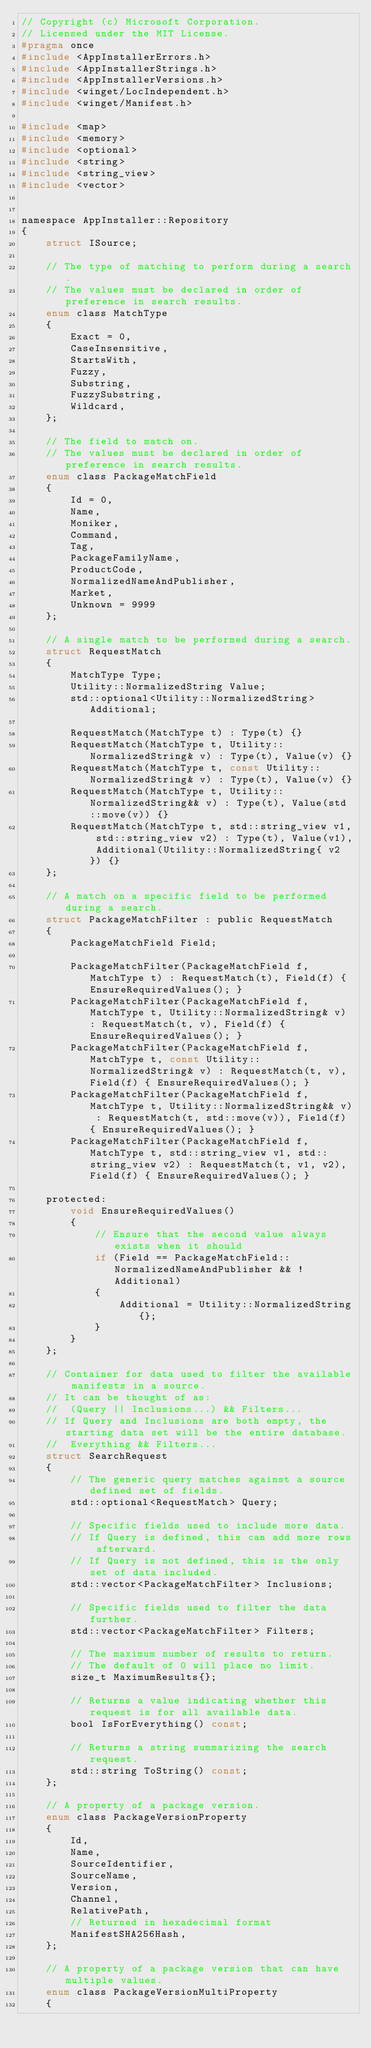<code> <loc_0><loc_0><loc_500><loc_500><_C_>// Copyright (c) Microsoft Corporation.
// Licensed under the MIT License.
#pragma once
#include <AppInstallerErrors.h>
#include <AppInstallerStrings.h>
#include <AppInstallerVersions.h>
#include <winget/LocIndependent.h>
#include <winget/Manifest.h>

#include <map>
#include <memory>
#include <optional>
#include <string>
#include <string_view>
#include <vector>


namespace AppInstaller::Repository
{
    struct ISource;

    // The type of matching to perform during a search.
    // The values must be declared in order of preference in search results.
    enum class MatchType
    {
        Exact = 0,
        CaseInsensitive,
        StartsWith,
        Fuzzy,
        Substring,
        FuzzySubstring,
        Wildcard,
    };

    // The field to match on.
    // The values must be declared in order of preference in search results.
    enum class PackageMatchField
    {
        Id = 0,
        Name,
        Moniker,
        Command,
        Tag,
        PackageFamilyName,
        ProductCode,
        NormalizedNameAndPublisher,
        Market,
        Unknown = 9999
    };

    // A single match to be performed during a search.
    struct RequestMatch
    {
        MatchType Type;
        Utility::NormalizedString Value;
        std::optional<Utility::NormalizedString> Additional;

        RequestMatch(MatchType t) : Type(t) {}
        RequestMatch(MatchType t, Utility::NormalizedString& v) : Type(t), Value(v) {}
        RequestMatch(MatchType t, const Utility::NormalizedString& v) : Type(t), Value(v) {}
        RequestMatch(MatchType t, Utility::NormalizedString&& v) : Type(t), Value(std::move(v)) {}
        RequestMatch(MatchType t, std::string_view v1, std::string_view v2) : Type(t), Value(v1), Additional(Utility::NormalizedString{ v2 }) {}
    };

    // A match on a specific field to be performed during a search.
    struct PackageMatchFilter : public RequestMatch
    {
        PackageMatchField Field;

        PackageMatchFilter(PackageMatchField f, MatchType t) : RequestMatch(t), Field(f) { EnsureRequiredValues(); }
        PackageMatchFilter(PackageMatchField f, MatchType t, Utility::NormalizedString& v) : RequestMatch(t, v), Field(f) { EnsureRequiredValues(); }
        PackageMatchFilter(PackageMatchField f, MatchType t, const Utility::NormalizedString& v) : RequestMatch(t, v), Field(f) { EnsureRequiredValues(); }
        PackageMatchFilter(PackageMatchField f, MatchType t, Utility::NormalizedString&& v) : RequestMatch(t, std::move(v)), Field(f) { EnsureRequiredValues(); }
        PackageMatchFilter(PackageMatchField f, MatchType t, std::string_view v1, std::string_view v2) : RequestMatch(t, v1, v2), Field(f) { EnsureRequiredValues(); }

    protected:
        void EnsureRequiredValues()
        {
            // Ensure that the second value always exists when it should
            if (Field == PackageMatchField::NormalizedNameAndPublisher && !Additional)
            {
                Additional = Utility::NormalizedString{};
            }
        }
    };

    // Container for data used to filter the available manifests in a source.
    // It can be thought of as:
    //  (Query || Inclusions...) && Filters...
    // If Query and Inclusions are both empty, the starting data set will be the entire database.
    //  Everything && Filters...
    struct SearchRequest
    {
        // The generic query matches against a source defined set of fields.
        std::optional<RequestMatch> Query;

        // Specific fields used to include more data.
        // If Query is defined, this can add more rows afterward.
        // If Query is not defined, this is the only set of data included.
        std::vector<PackageMatchFilter> Inclusions;

        // Specific fields used to filter the data further.
        std::vector<PackageMatchFilter> Filters;

        // The maximum number of results to return.
        // The default of 0 will place no limit.
        size_t MaximumResults{};

        // Returns a value indicating whether this request is for all available data.
        bool IsForEverything() const;

        // Returns a string summarizing the search request.
        std::string ToString() const;
    };

    // A property of a package version.
    enum class PackageVersionProperty
    {
        Id,
        Name,
        SourceIdentifier,
        SourceName,
        Version,
        Channel,
        RelativePath,
        // Returned in hexadecimal format
        ManifestSHA256Hash,
    };

    // A property of a package version that can have multiple values.
    enum class PackageVersionMultiProperty
    {</code> 